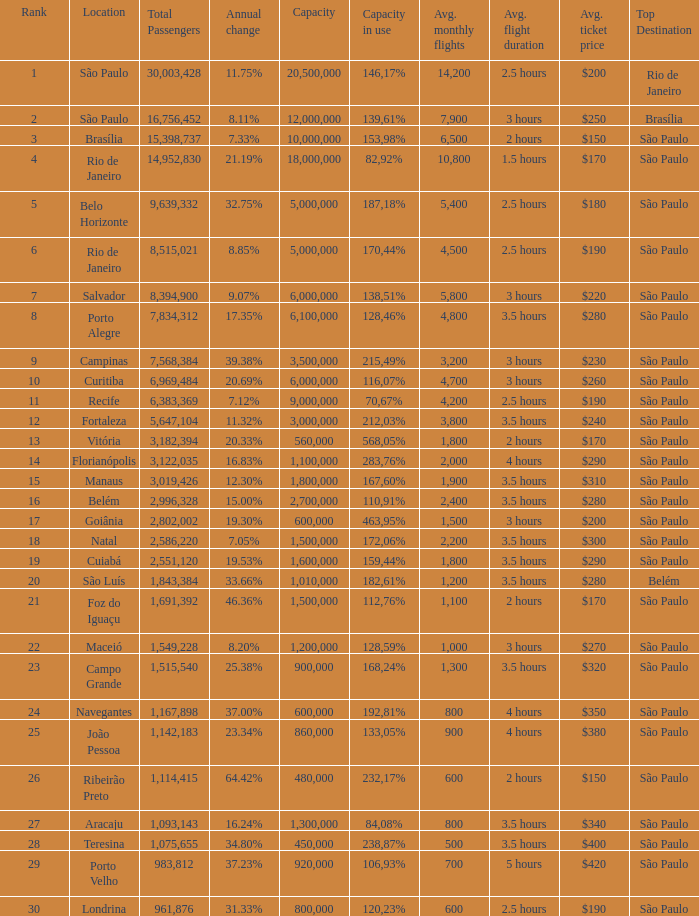Which location has a capacity that has a rank of 23? 168,24%. 